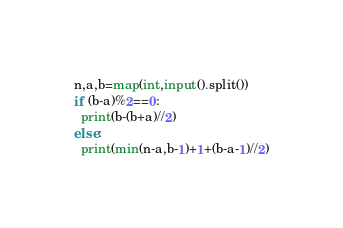<code> <loc_0><loc_0><loc_500><loc_500><_Python_>n,a,b=map(int,input().split())
if (b-a)%2==0:
  print(b-(b+a)//2)
else:
  print(min(n-a,b-1)+1+(b-a-1)//2)</code> 